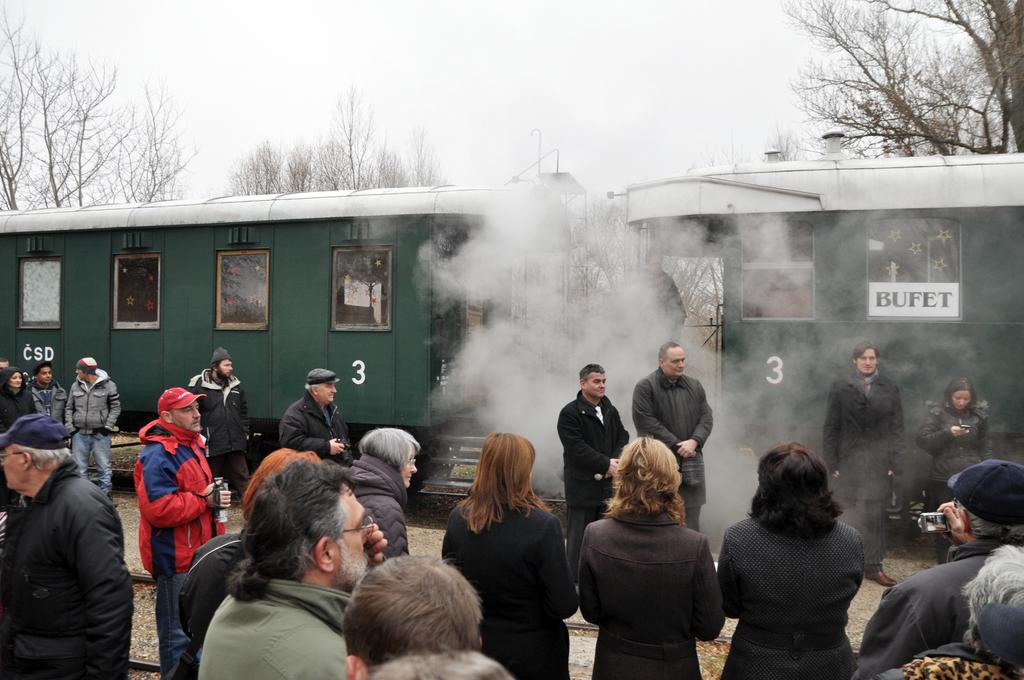Who or what is present in the image? There are people in the image. What can be seen in the background of the image? There is a train and trees in the background of the image. Can you describe the train in the image? The train has text written on it. What else is visible in the background of the image? The sky is visible in the background of the image. What type of animal can be seen flying in the image? There is no animal flying in the image; it only features people, a train, trees, and the sky. 